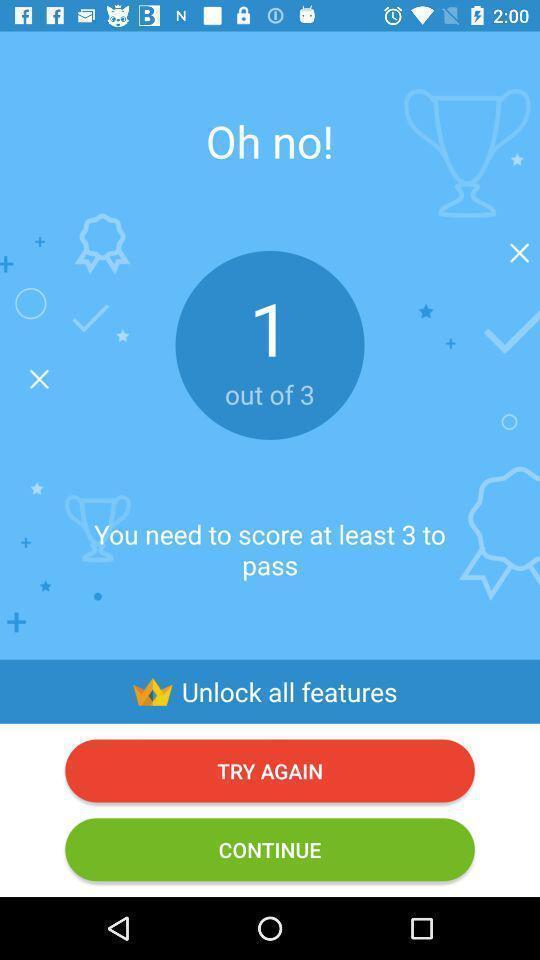Summarize the main components in this picture. Screen showing score page of a learning app. 